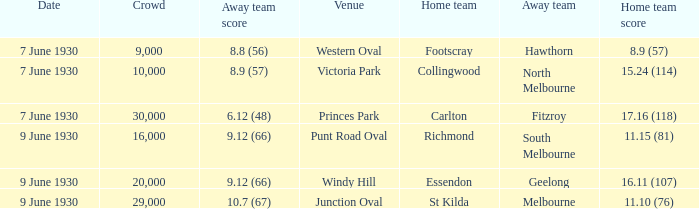What is the average crowd to watch Hawthorn as the away team? 9000.0. 